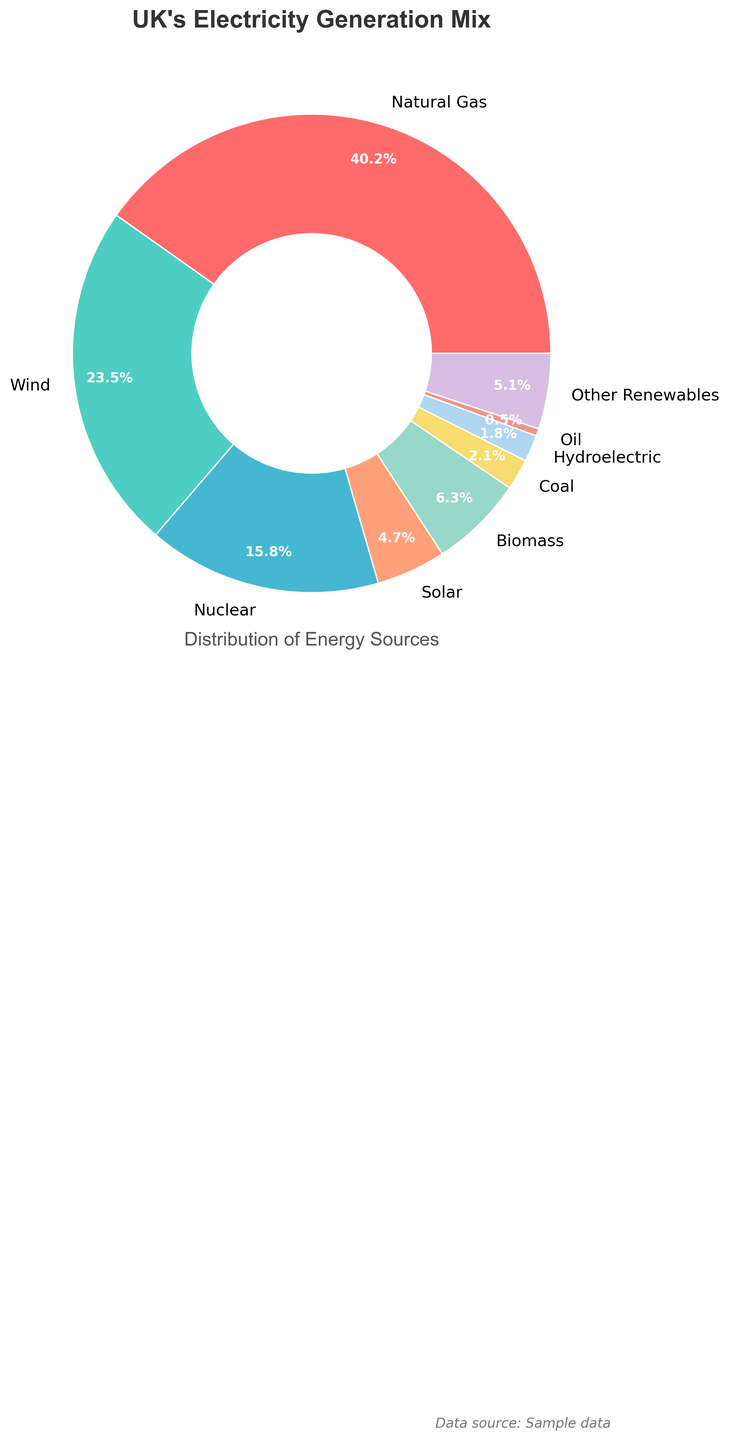Which energy source contributes the most to the UK's electricity generation mix? The largest segment in the pie chart represents the energy source with the highest percentage. The segment labeled "Natural Gas" takes up the largest portion of the pie chart at 40.2%.
Answer: Natural Gas How does the contribution of wind energy compare to that of nuclear energy? To compare, look at the percentages of wind and nuclear energy. Wind energy is at 23.5% while nuclear energy is at 15.8%. Wind energy contributes more than nuclear energy.
Answer: Wind energy contributes more What's the sum of the percentage contributions of solar, biomass, and coal? Add the percentages of solar (4.7%), biomass (6.3%), and coal (2.1%). 4.7 + 6.3 + 2.1 = 13.1%.
Answer: 13.1% How much more does natural gas contribute than coal? Subtract the percentage of coal (2.1%) from the percentage of natural gas (40.2%). 40.2 - 2.1 = 38.1%.
Answer: 38.1% What is the combined percentage of all renewable sources? Renewable sources in the chart include wind (23.5%), solar (4.7%), biomass (6.3%), hydroelectric (1.8%), and other renewables (5.1%). Add these percentages together. 23.5 + 4.7 + 6.3 + 1.8 + 5.1 = 41.4%.
Answer: 41.4% Which energy source is represented by the light blue section in the pie chart? Identify the color coding to verify the energy source represented by light blue. The light blue section corresponds to "Hydroelectric" at 1.8%.
Answer: Hydroelectric Is the contribution of oil more than 1%? Look at the segment labeled "Oil" and check its percentage. The contribution of oil is 0.5%, which is less than 1%.
Answer: No How does the smallest segment compare with the largest segment in terms of percentage contribution? The smallest segment is oil at 0.5%, and the largest segment is natural gas at 40.2%. Subtract the percentage of oil from the percentage of natural gas. 40.2 - 0.5 = 39.7%.
Answer: Oil is 39.7% less 